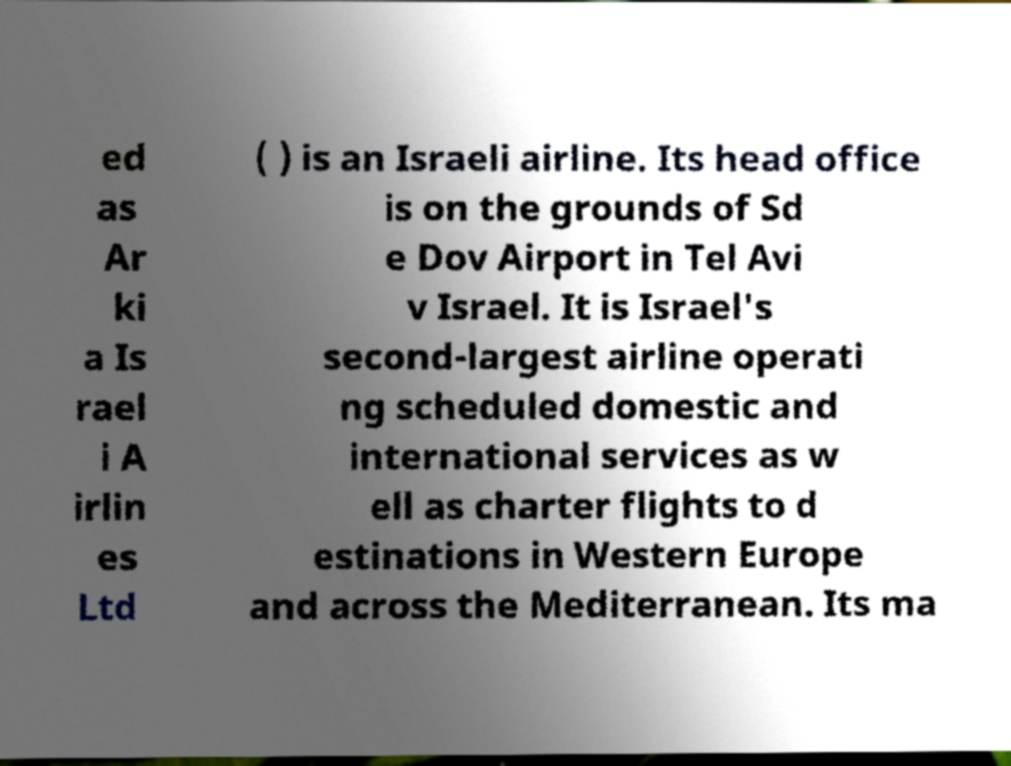Please read and relay the text visible in this image. What does it say? ed as Ar ki a Is rael i A irlin es Ltd ( ) is an Israeli airline. Its head office is on the grounds of Sd e Dov Airport in Tel Avi v Israel. It is Israel's second-largest airline operati ng scheduled domestic and international services as w ell as charter flights to d estinations in Western Europe and across the Mediterranean. Its ma 